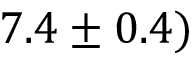Convert formula to latex. <formula><loc_0><loc_0><loc_500><loc_500>7 . 4 \pm 0 . 4 )</formula> 